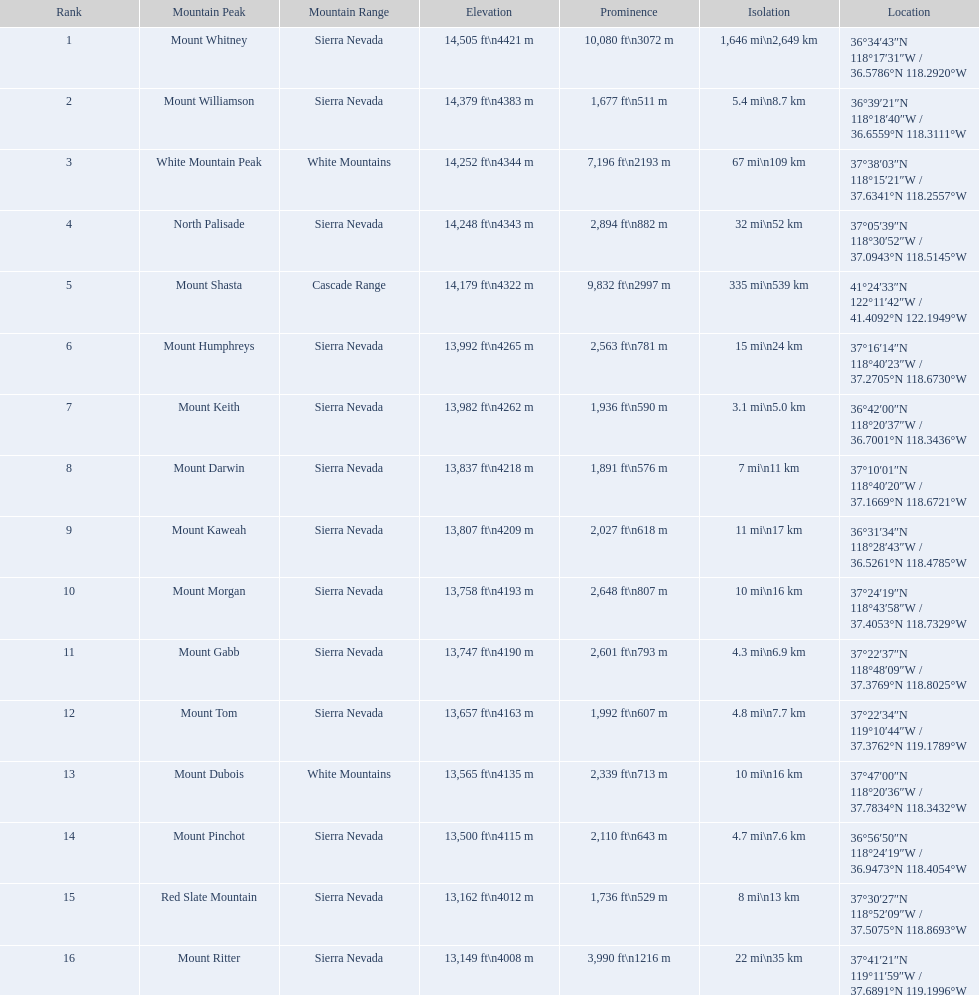What are all of the mountain peaks? Mount Whitney, Mount Williamson, White Mountain Peak, North Palisade, Mount Shasta, Mount Humphreys, Mount Keith, Mount Darwin, Mount Kaweah, Mount Morgan, Mount Gabb, Mount Tom, Mount Dubois, Mount Pinchot, Red Slate Mountain, Mount Ritter. In what ranges are they located? Sierra Nevada, Sierra Nevada, White Mountains, Sierra Nevada, Cascade Range, Sierra Nevada, Sierra Nevada, Sierra Nevada, Sierra Nevada, Sierra Nevada, Sierra Nevada, Sierra Nevada, White Mountains, Sierra Nevada, Sierra Nevada, Sierra Nevada. And which mountain peak is in the cascade range? Mount Shasta. Which mountain peak is a part of the white mountains range? White Mountain Peak. Which mountain is included in the sierra nevada range? Mount Whitney. Which single mountain exists in the cascade range? Mount Shasta. 